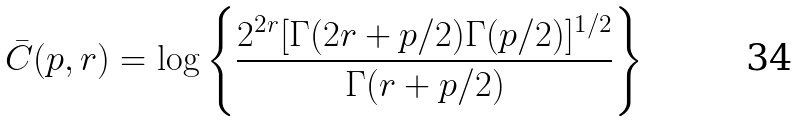Convert formula to latex. <formula><loc_0><loc_0><loc_500><loc_500>\bar { C } ( p , r ) = \log \left \{ \frac { 2 ^ { 2 r } [ \Gamma ( 2 r + p / 2 ) \Gamma ( p / 2 ) ] ^ { 1 / 2 } } { \Gamma ( r + p / 2 ) } \right \}</formula> 